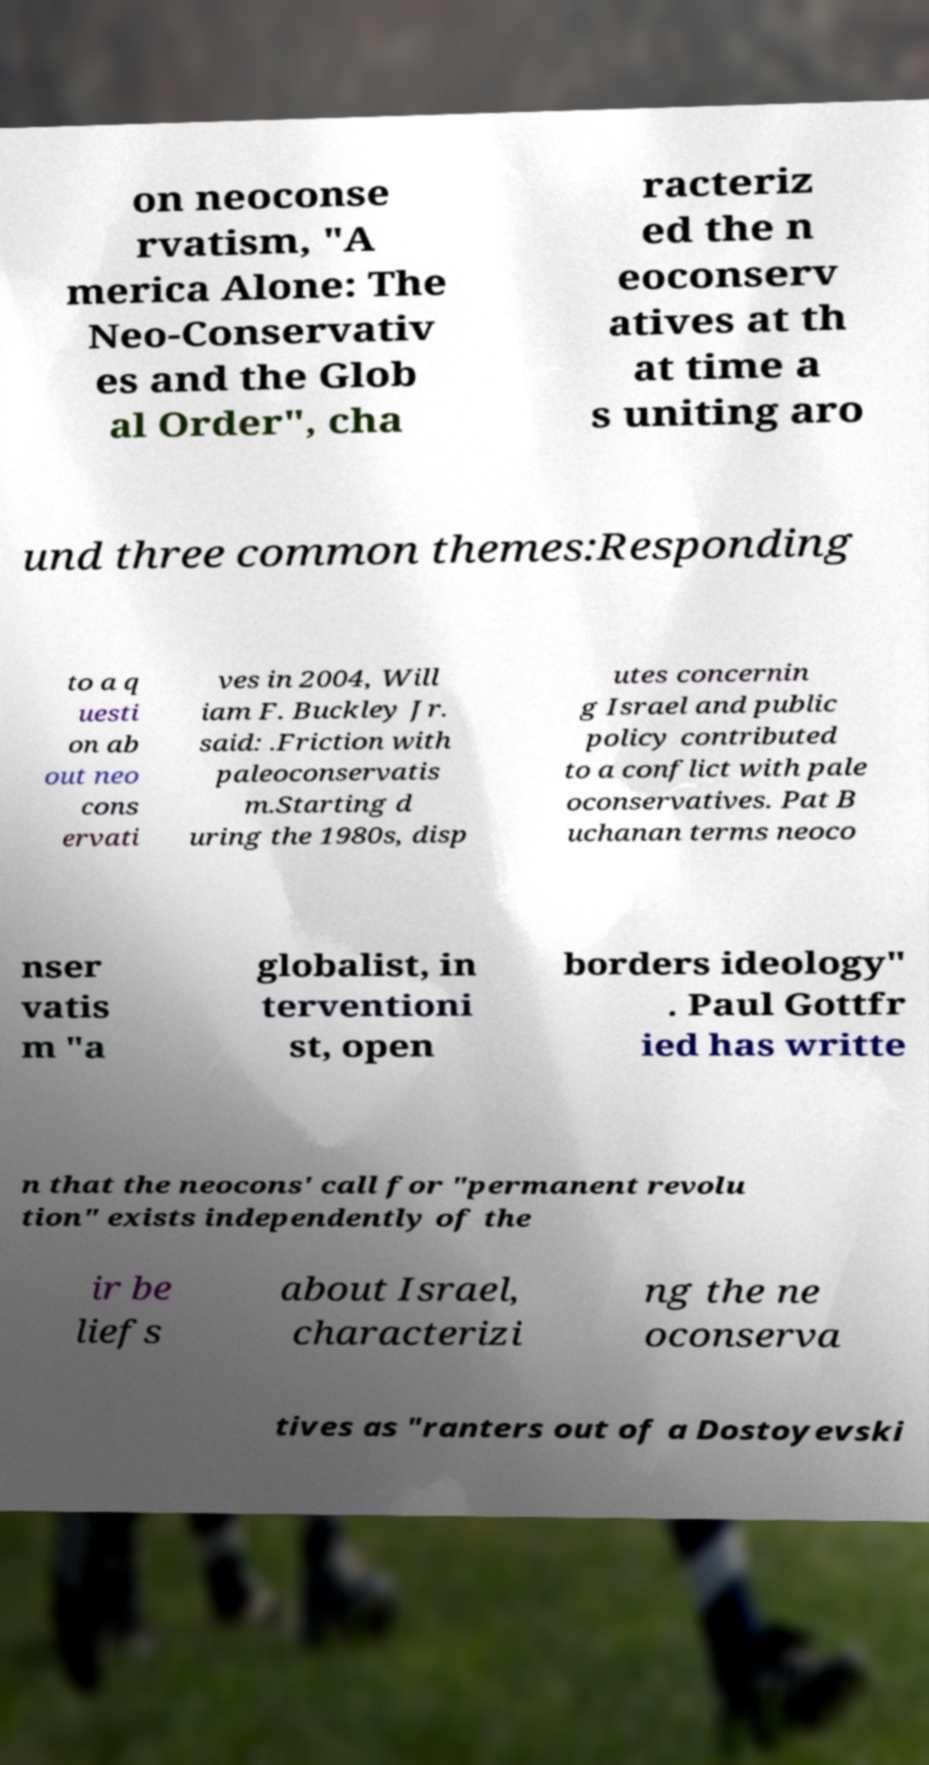For documentation purposes, I need the text within this image transcribed. Could you provide that? on neoconse rvatism, "A merica Alone: The Neo-Conservativ es and the Glob al Order", cha racteriz ed the n eoconserv atives at th at time a s uniting aro und three common themes:Responding to a q uesti on ab out neo cons ervati ves in 2004, Will iam F. Buckley Jr. said: .Friction with paleoconservatis m.Starting d uring the 1980s, disp utes concernin g Israel and public policy contributed to a conflict with pale oconservatives. Pat B uchanan terms neoco nser vatis m "a globalist, in terventioni st, open borders ideology" . Paul Gottfr ied has writte n that the neocons' call for "permanent revolu tion" exists independently of the ir be liefs about Israel, characterizi ng the ne oconserva tives as "ranters out of a Dostoyevski 